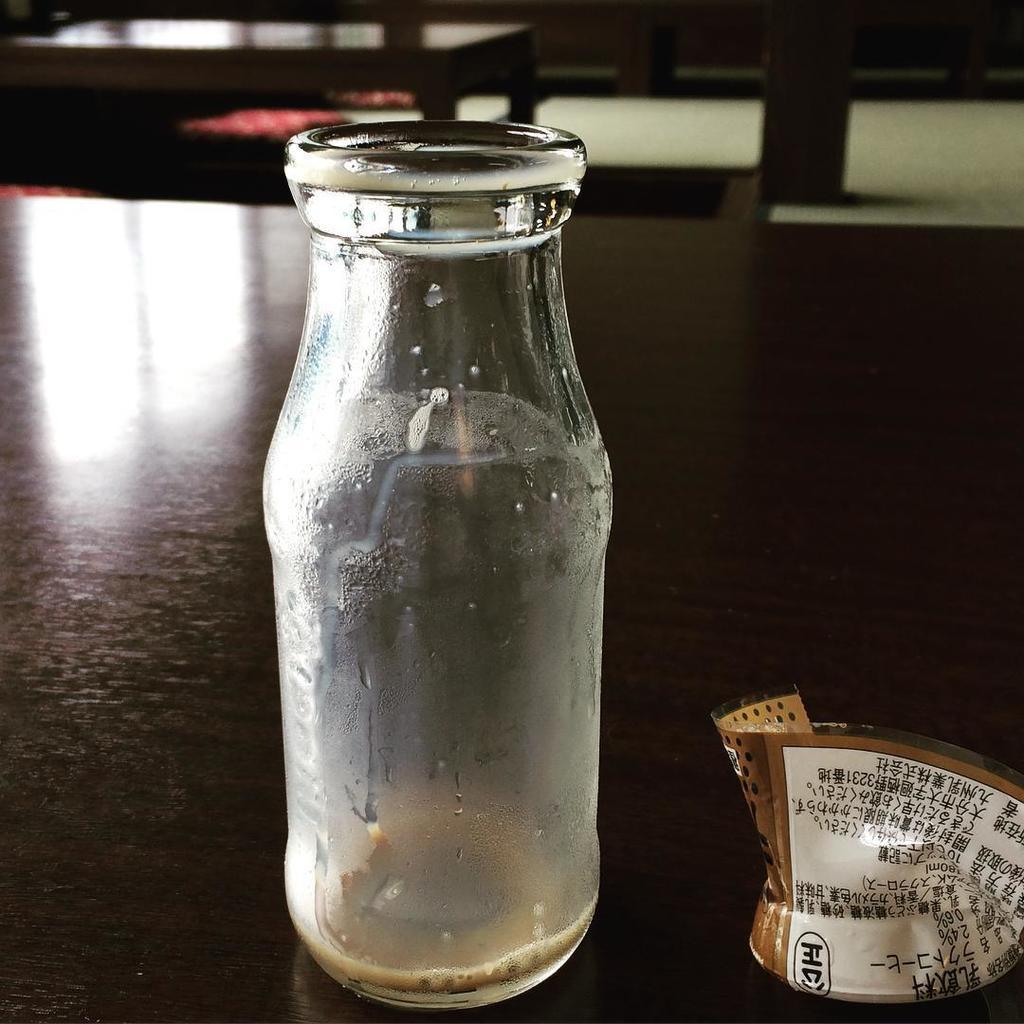How would you summarize this image in a sentence or two? There is an empty bottle and the label of the bottle is torn and kept beside the bottle on a table. 